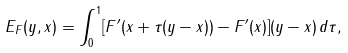<formula> <loc_0><loc_0><loc_500><loc_500>E _ { F } ( y , x ) = \int _ { 0 } ^ { 1 } [ F ^ { \prime } ( x + \tau ( y - x ) ) - F ^ { \prime } ( x ) ] ( y - x ) \, d \tau ,</formula> 